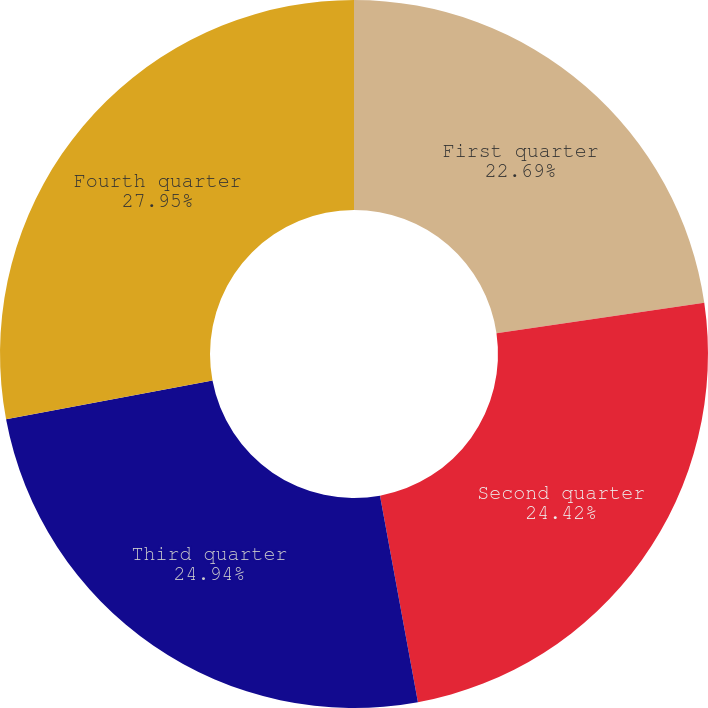Convert chart. <chart><loc_0><loc_0><loc_500><loc_500><pie_chart><fcel>First quarter<fcel>Second quarter<fcel>Third quarter<fcel>Fourth quarter<nl><fcel>22.69%<fcel>24.42%<fcel>24.94%<fcel>27.95%<nl></chart> 